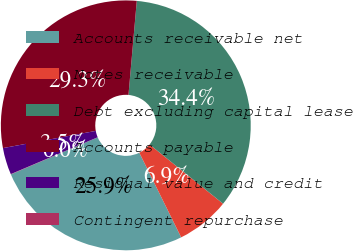<chart> <loc_0><loc_0><loc_500><loc_500><pie_chart><fcel>Accounts receivable net<fcel>Notes receivable<fcel>Debt excluding capital lease<fcel>Accounts payable<fcel>Residual value and credit<fcel>Contingent repurchase<nl><fcel>25.89%<fcel>6.9%<fcel>34.39%<fcel>29.32%<fcel>3.47%<fcel>0.03%<nl></chart> 